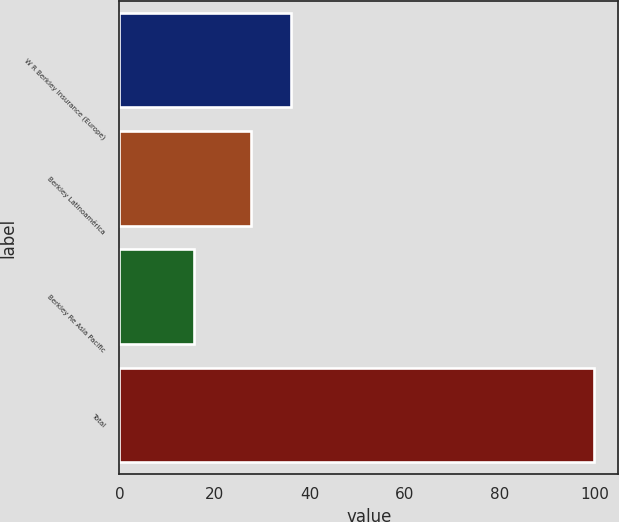Convert chart. <chart><loc_0><loc_0><loc_500><loc_500><bar_chart><fcel>W R Berkley Insurance (Europe)<fcel>Berkley Latinoamérica<fcel>Berkley Re Asia Pacific<fcel>Total<nl><fcel>36.13<fcel>27.7<fcel>15.7<fcel>100<nl></chart> 